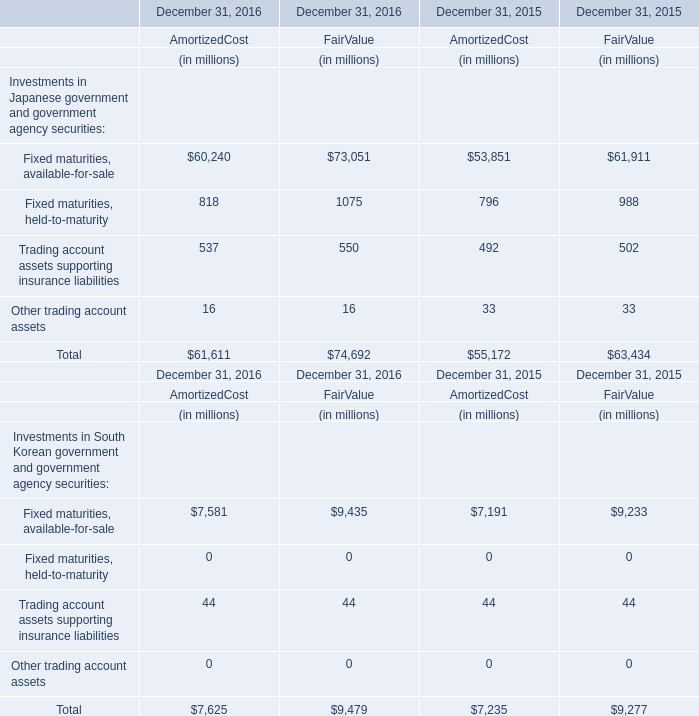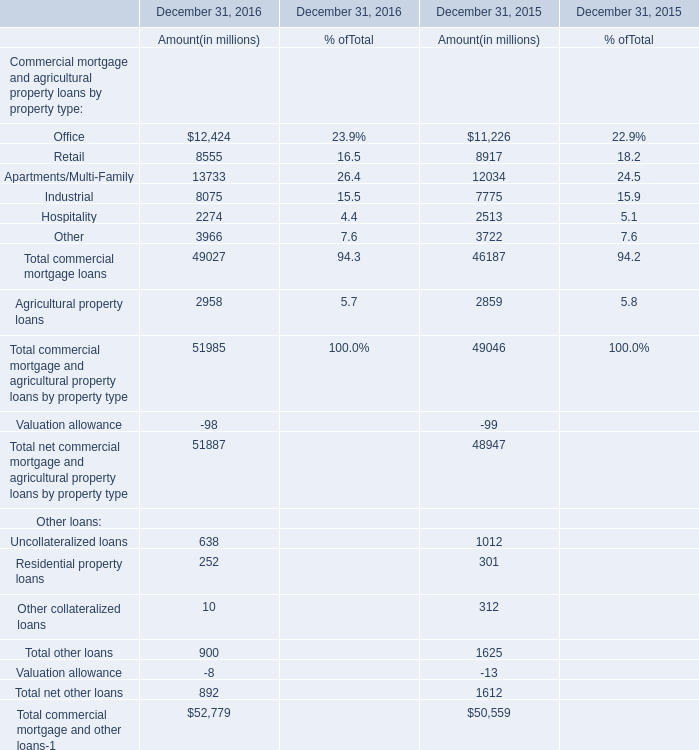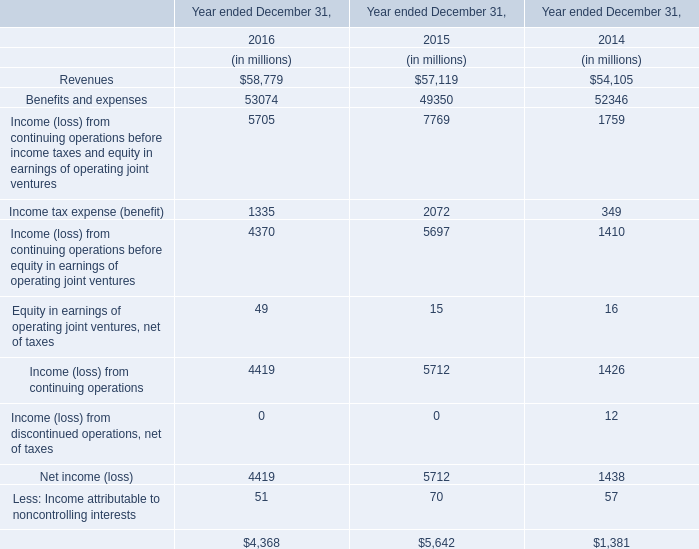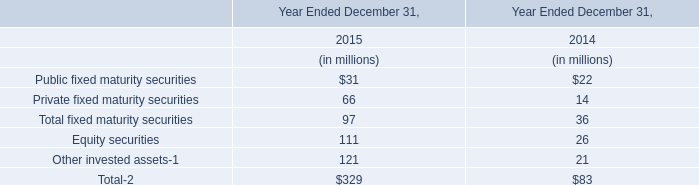What is the difference between 2015 and 2016 's highest Office for amount ? (in million) 
Computations: (12424 - 11226)
Answer: 1198.0. 